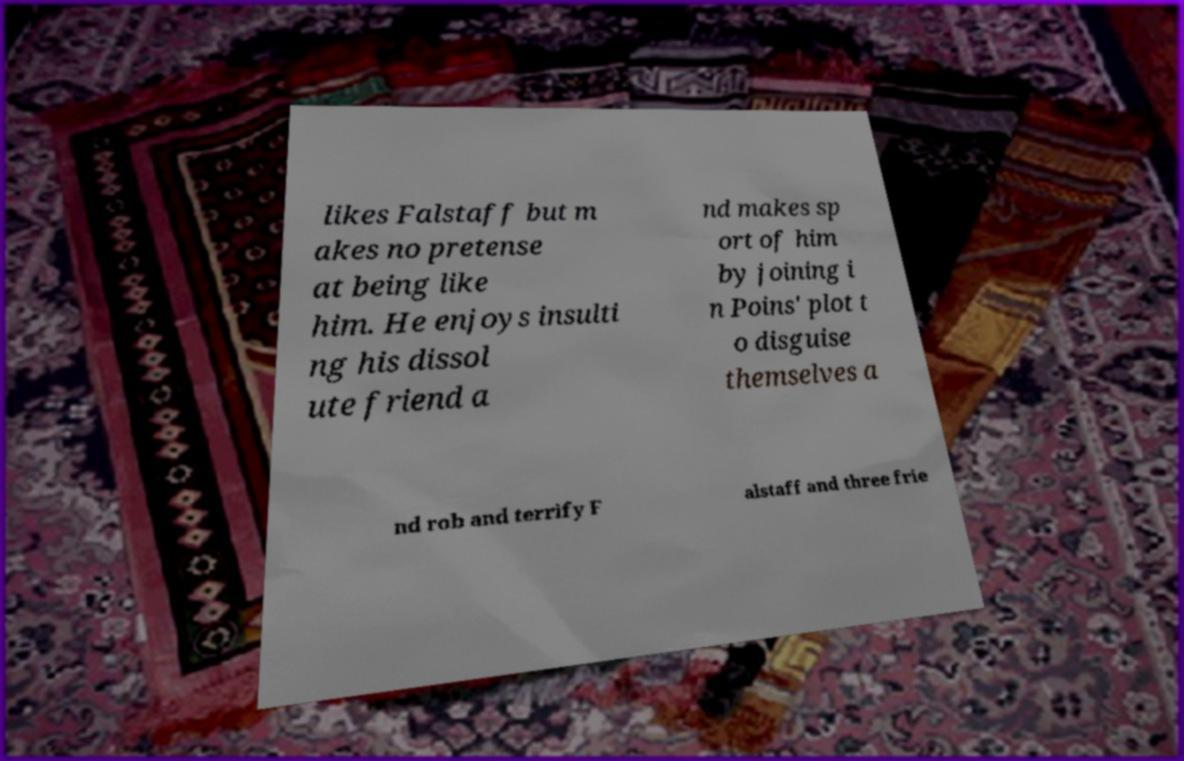Please identify and transcribe the text found in this image. likes Falstaff but m akes no pretense at being like him. He enjoys insulti ng his dissol ute friend a nd makes sp ort of him by joining i n Poins' plot t o disguise themselves a nd rob and terrify F alstaff and three frie 